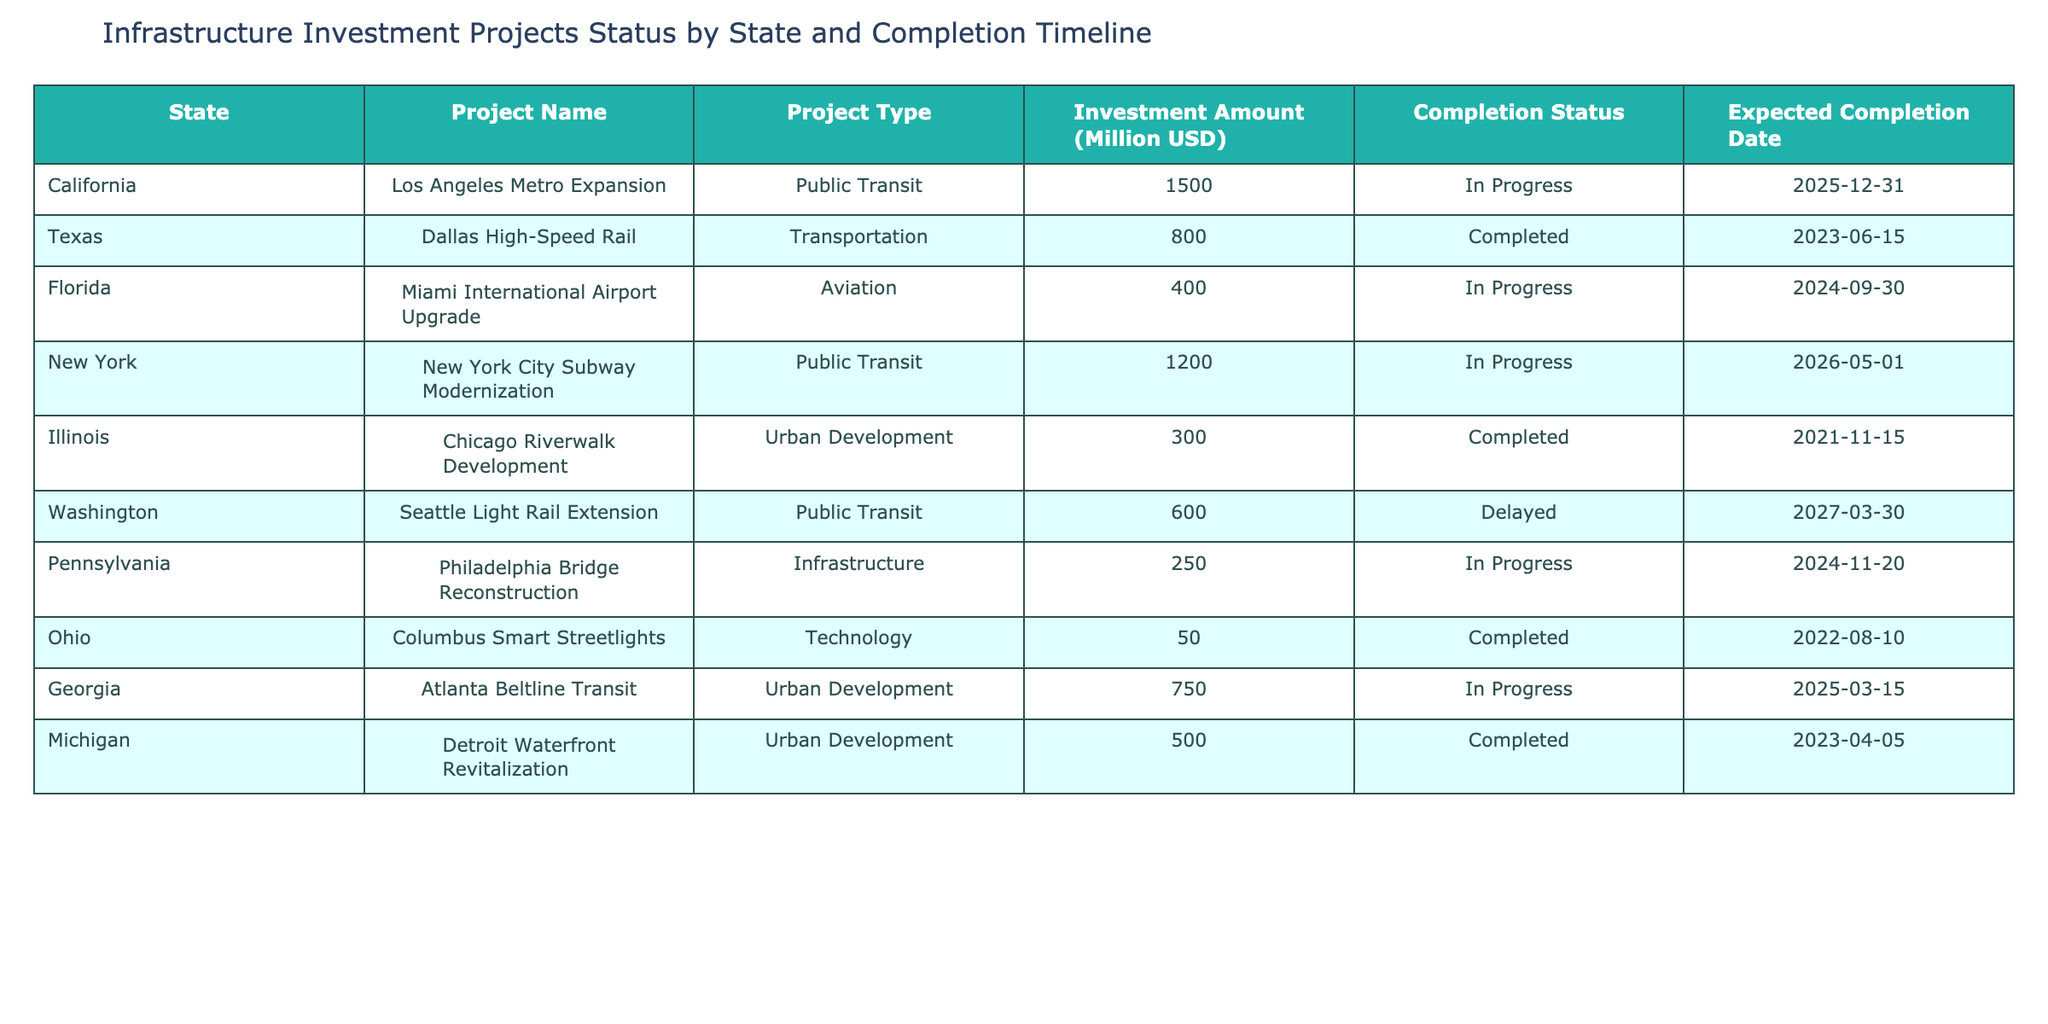What is the expected completion date for the Miami International Airport Upgrade project? The table indicates that the expected completion date for the Miami International Airport Upgrade is listed under the "Expected Completion Date" column, which shows "2024-09-30."
Answer: 2024-09-30 Which state has the highest investment amount, and what is that amount? By looking at the "Investment Amount (Million USD)" column, California with the Los Angeles Metro Expansion project shows the highest investment at 1500 million USD.
Answer: California, 1500 million USD Is the Philadelphia Bridge Reconstruction project still in progress? Checking the "Completion Status" column for Philadelphia Bridge Reconstruction, it is listed as "In Progress," confirming that the project is still ongoing.
Answer: Yes What is the total investment amount for projects that are completed? To find this, we sum the investment amounts for the completed projects: Dallas High-Speed Rail (800) + Chicago Riverwalk Development (300) + Columbus Smart Streetlights (50) + Detroit Waterfront Revitalization (500) = 1650 million USD.
Answer: 1650 million USD How many projects are delayed, and what is the name of the project? The table shows one project with "Delayed" status—Seattle Light Rail Extension. This is the only project marked as such, indicating there are a total of one delayed project.
Answer: 1 project, Seattle Light Rail Extension What percentage of the total projects listed are currently in progress? There are a total of 10 projects listed. Out of these, 5 are in progress: Los Angeles Metro Expansion, Miami International Airport Upgrade, New York City Subway Modernization, Philadelphia Bridge Reconstruction, and Atlanta Beltline Transit. Therefore, the percentage of projects in progress is (5/10) * 100 = 50%.
Answer: 50% Which type of project has the most investment among the projects that are completed? The completed projects are: Dallas High-Speed Rail (800), Chicago Riverwalk Development (300), Columbus Smart Streetlights (50), and Detroit Waterfront Revitalization (500). Among these, the Transportation type (Dallas High-Speed Rail) has the highest investment at 800 million USD.
Answer: Transportation, 800 million USD Are there any projects with an expected completion date in 2024? Yes, both the Miami International Airport Upgrade (2024-09-30) and Philadelphia Bridge Reconstruction (2024-11-20) are due for completion in 2024. Therefore, the answer is yes, multiple projects have dates in 2024.
Answer: Yes What is the average investment amount for the projects that are in progress? The projects that are in progress are: Los Angeles Metro Expansion (1500), Miami International Airport Upgrade (400), New York City Subway Modernization (1200), Philadelphia Bridge Reconstruction (250), and Atlanta Beltline Transit (750). The total investment for these is 1500 + 400 + 1200 + 250 + 750 = 4100 million USD; dividing by 5 gives an average of 820 million USD.
Answer: 820 million USD 